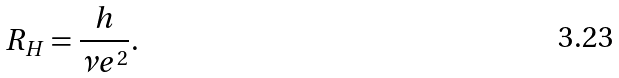Convert formula to latex. <formula><loc_0><loc_0><loc_500><loc_500>R _ { H } = \frac { h } { \nu e ^ { 2 } } .</formula> 